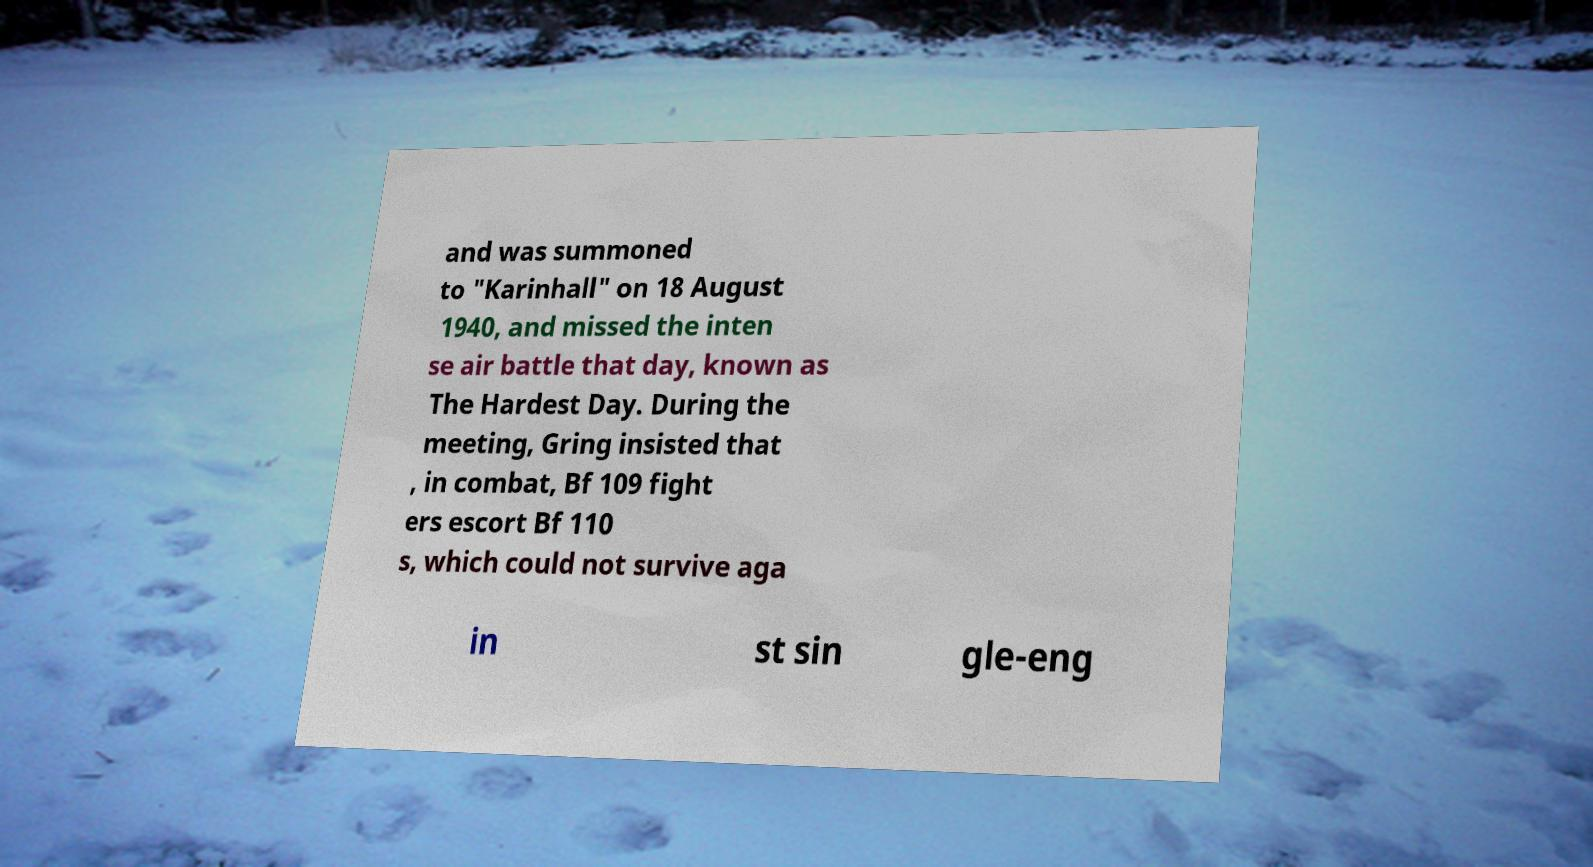I need the written content from this picture converted into text. Can you do that? and was summoned to "Karinhall" on 18 August 1940, and missed the inten se air battle that day, known as The Hardest Day. During the meeting, Gring insisted that , in combat, Bf 109 fight ers escort Bf 110 s, which could not survive aga in st sin gle-eng 